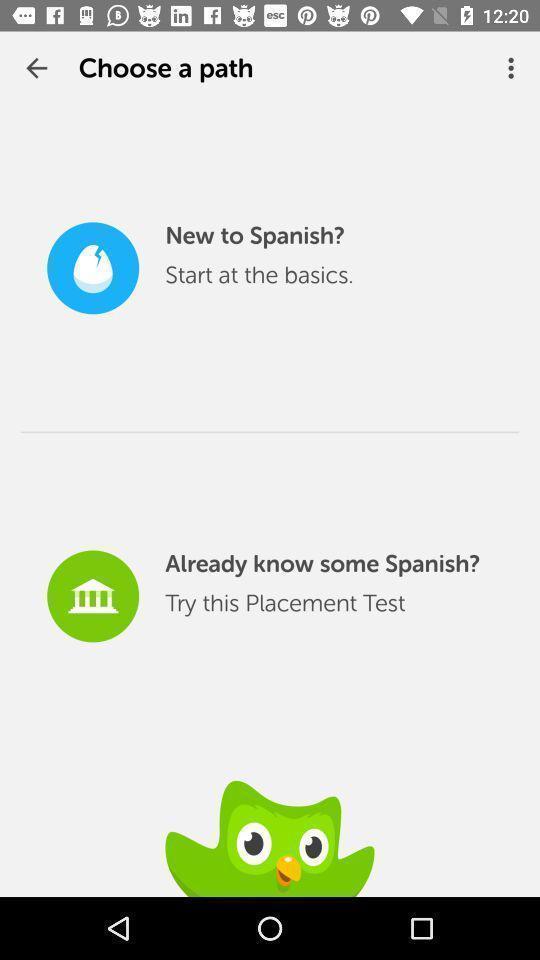Tell me about the visual elements in this screen capture. Screen displaying the page to choose a path. 